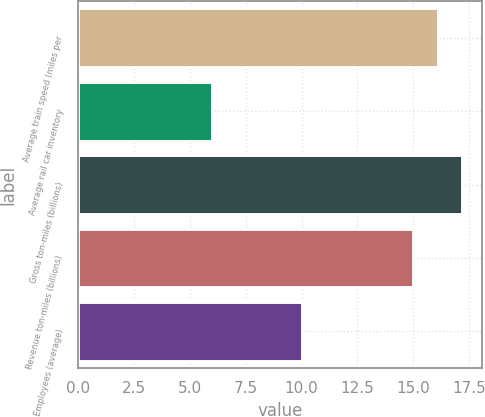Convert chart to OTSL. <chart><loc_0><loc_0><loc_500><loc_500><bar_chart><fcel>Average train speed (miles per<fcel>Average rail car inventory<fcel>Gross ton-miles (billions)<fcel>Revenue ton-miles (billions)<fcel>Employees (average)<nl><fcel>16.1<fcel>6<fcel>17.2<fcel>15<fcel>10<nl></chart> 